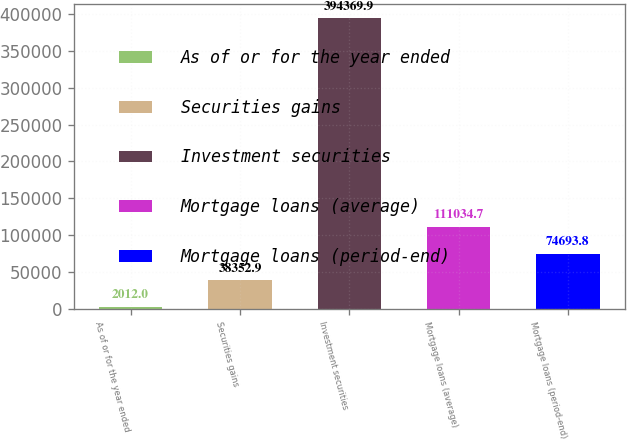<chart> <loc_0><loc_0><loc_500><loc_500><bar_chart><fcel>As of or for the year ended<fcel>Securities gains<fcel>Investment securities<fcel>Mortgage loans (average)<fcel>Mortgage loans (period-end)<nl><fcel>2012<fcel>38352.9<fcel>394370<fcel>111035<fcel>74693.8<nl></chart> 